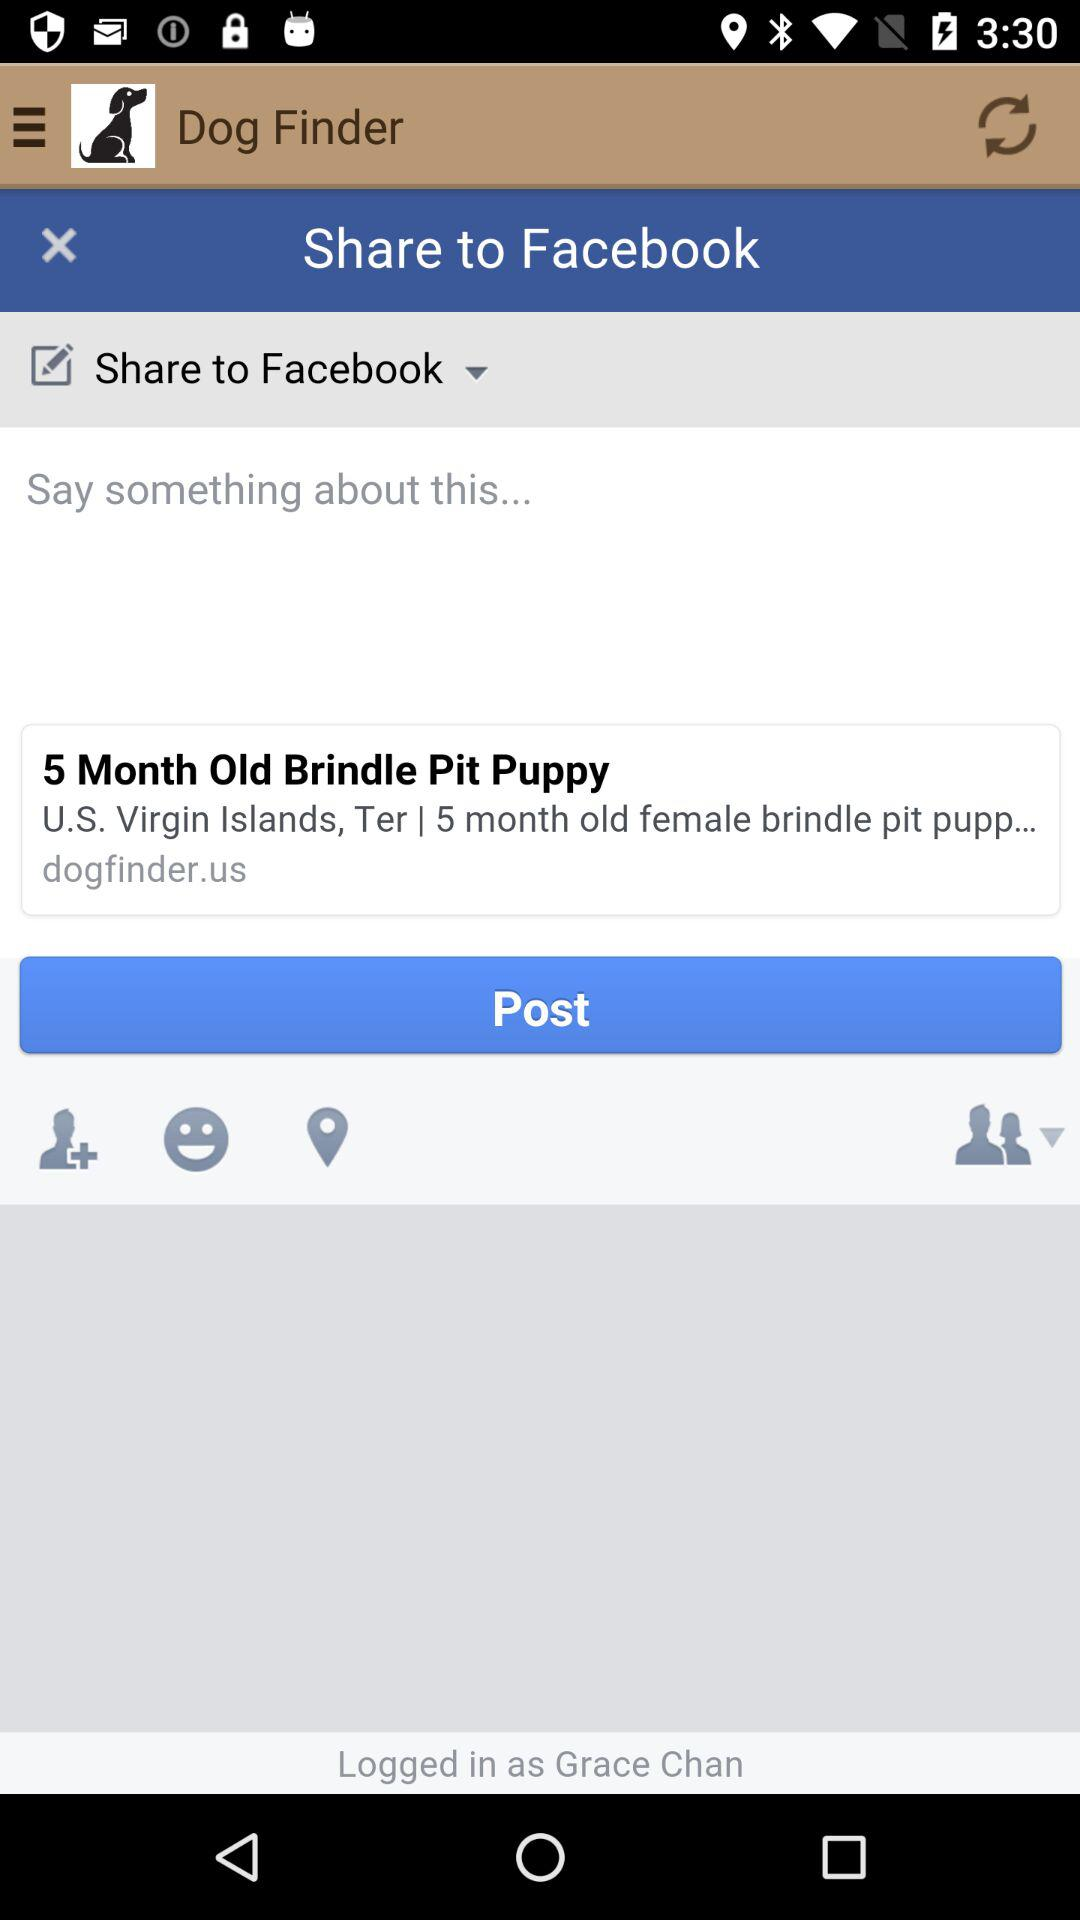What is the name of the application? The name of the application is "Dog Finder". 